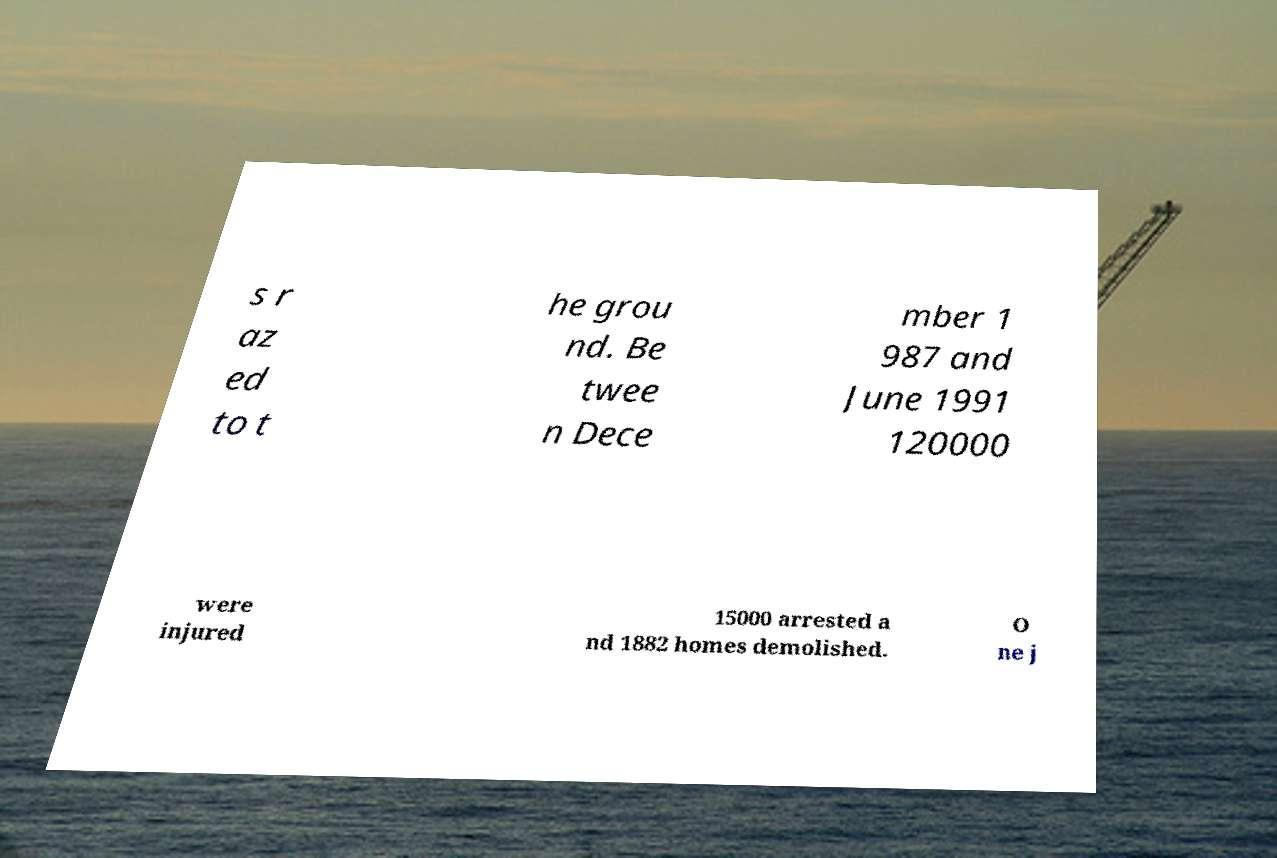What messages or text are displayed in this image? I need them in a readable, typed format. s r az ed to t he grou nd. Be twee n Dece mber 1 987 and June 1991 120000 were injured 15000 arrested a nd 1882 homes demolished. O ne j 